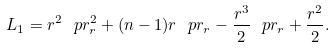Convert formula to latex. <formula><loc_0><loc_0><loc_500><loc_500>L _ { 1 } = r ^ { 2 } \ p r _ { r } ^ { 2 } + ( n - 1 ) r \ p r _ { r } - \frac { r ^ { 3 } } { 2 } \ p r _ { r } + \frac { r ^ { 2 } } { 2 } .</formula> 